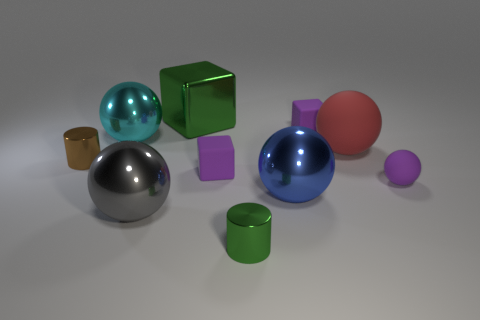Are there any objects that might indicate the size scale of the scene? Without familiar objects to contextualize the size, it's challenging to determine the exact scale of the scene precisely. However, the cubes and spheres possess properties akin to common geometric shapes, which might suggest a sense of scale when considering typical sizes for such items in real life. 